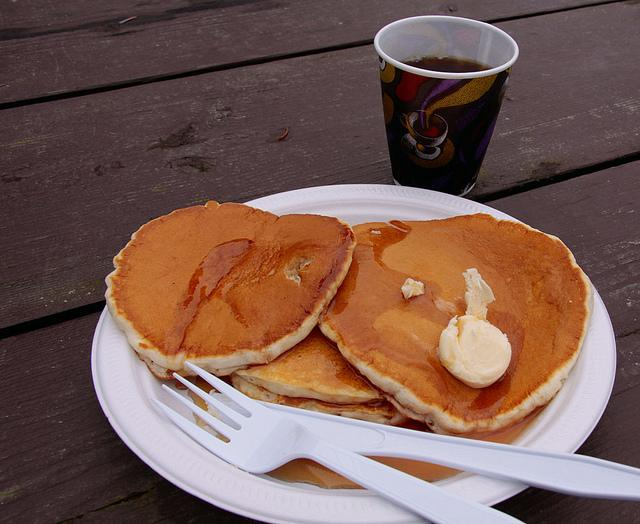On what surface is this plate of pancakes placed upon?

Choices:
A) kitchen counter
B) dining table
C) desk
D) park bench park bench 